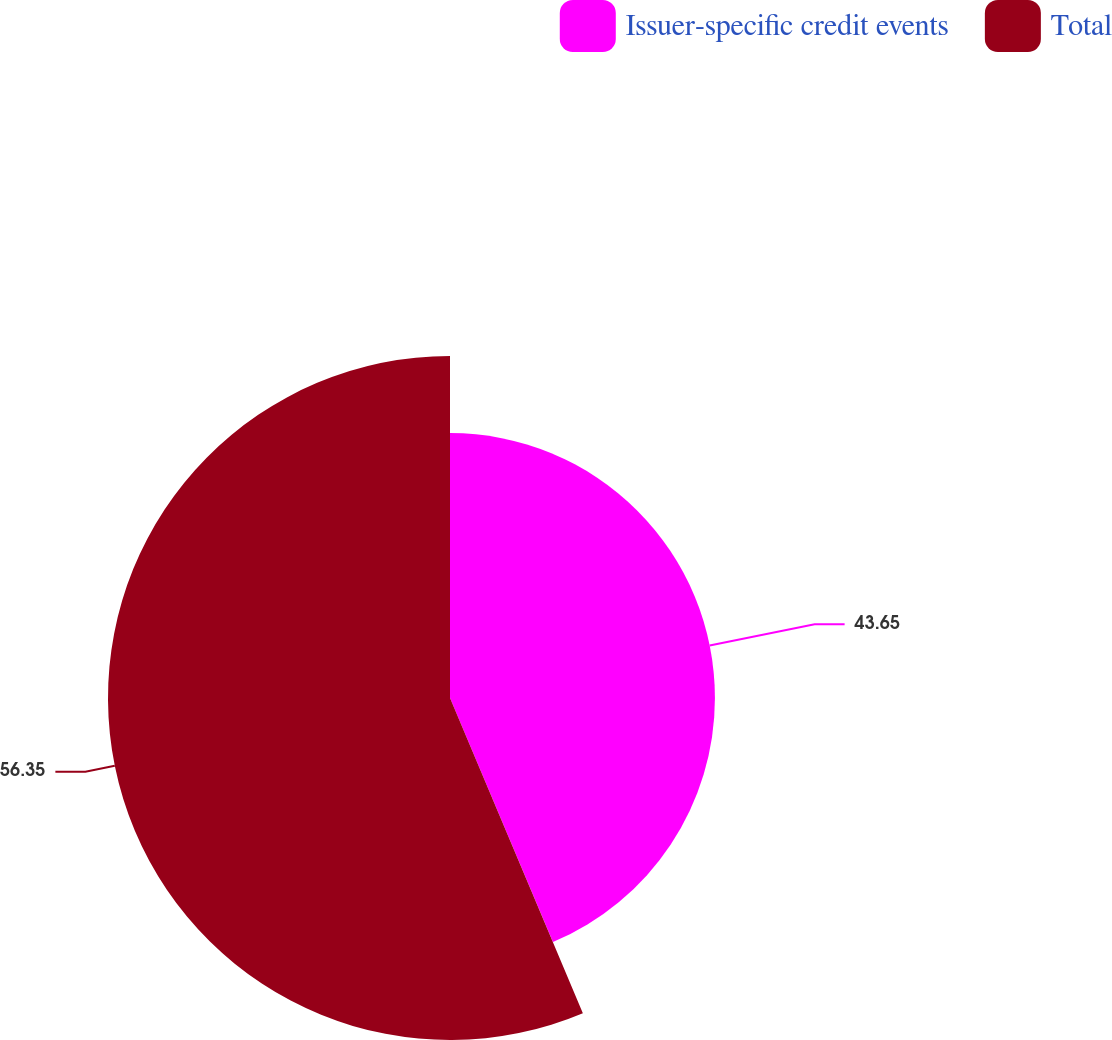Convert chart. <chart><loc_0><loc_0><loc_500><loc_500><pie_chart><fcel>Issuer-specific credit events<fcel>Total<nl><fcel>43.65%<fcel>56.35%<nl></chart> 